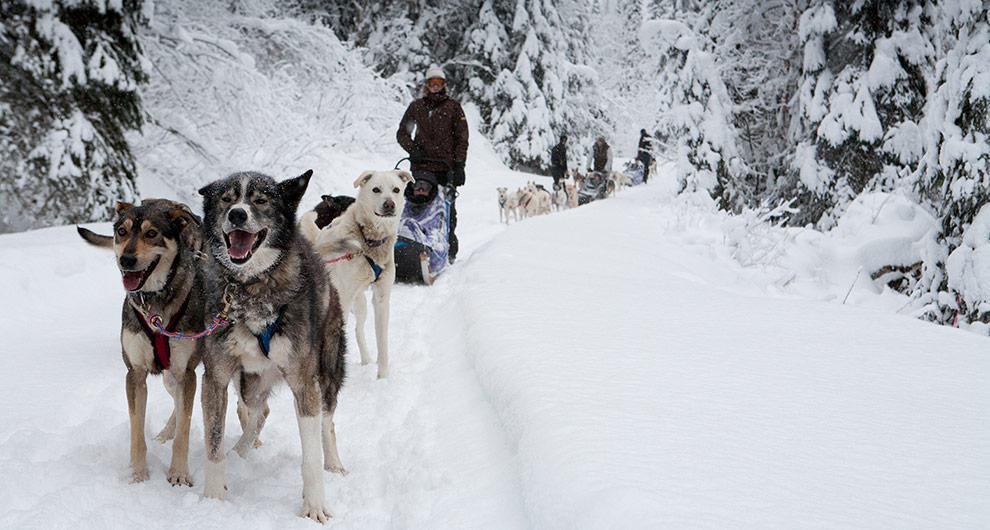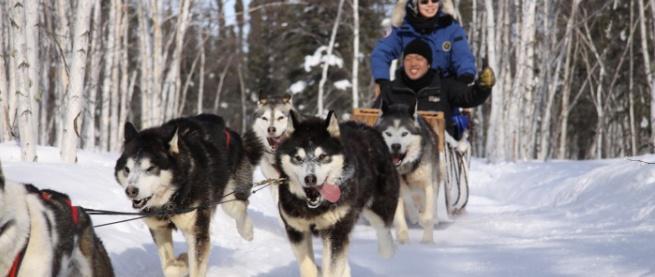The first image is the image on the left, the second image is the image on the right. Examine the images to the left and right. Is the description "One image shows one dog sled team being led by a man in a red jacket." accurate? Answer yes or no. No. The first image is the image on the left, the second image is the image on the right. For the images shown, is this caption "The right image has a man on a sled with a red jacket" true? Answer yes or no. No. 